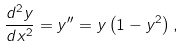<formula> <loc_0><loc_0><loc_500><loc_500>\frac { d ^ { 2 } y } { d x ^ { 2 } } = y ^ { \prime \prime } = y \left ( 1 - y ^ { 2 } \right ) ,</formula> 